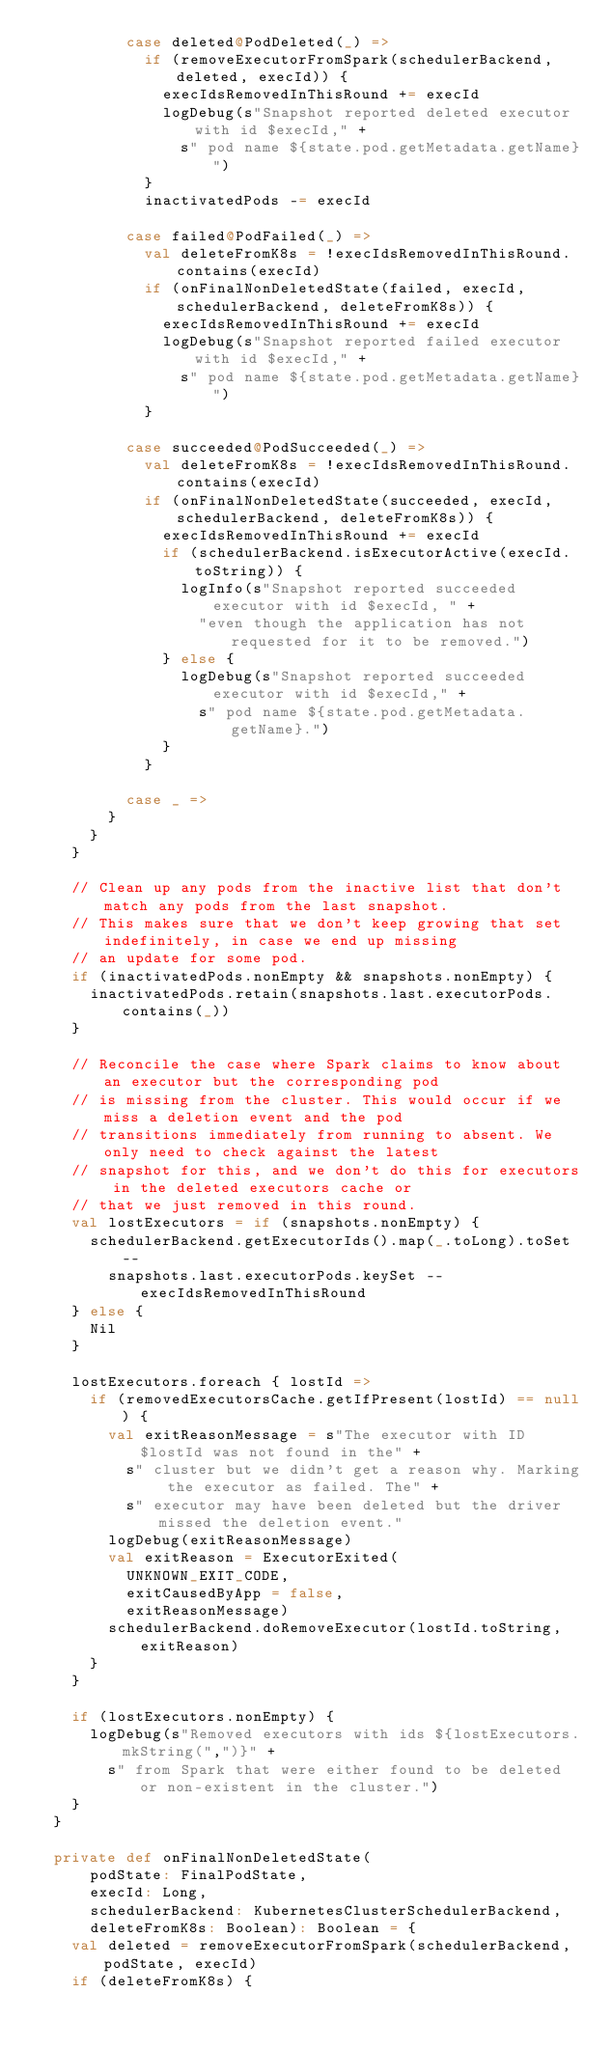<code> <loc_0><loc_0><loc_500><loc_500><_Scala_>          case deleted@PodDeleted(_) =>
            if (removeExecutorFromSpark(schedulerBackend, deleted, execId)) {
              execIdsRemovedInThisRound += execId
              logDebug(s"Snapshot reported deleted executor with id $execId," +
                s" pod name ${state.pod.getMetadata.getName}")
            }
            inactivatedPods -= execId

          case failed@PodFailed(_) =>
            val deleteFromK8s = !execIdsRemovedInThisRound.contains(execId)
            if (onFinalNonDeletedState(failed, execId, schedulerBackend, deleteFromK8s)) {
              execIdsRemovedInThisRound += execId
              logDebug(s"Snapshot reported failed executor with id $execId," +
                s" pod name ${state.pod.getMetadata.getName}")
            }

          case succeeded@PodSucceeded(_) =>
            val deleteFromK8s = !execIdsRemovedInThisRound.contains(execId)
            if (onFinalNonDeletedState(succeeded, execId, schedulerBackend, deleteFromK8s)) {
              execIdsRemovedInThisRound += execId
              if (schedulerBackend.isExecutorActive(execId.toString)) {
                logInfo(s"Snapshot reported succeeded executor with id $execId, " +
                  "even though the application has not requested for it to be removed.")
              } else {
                logDebug(s"Snapshot reported succeeded executor with id $execId," +
                  s" pod name ${state.pod.getMetadata.getName}.")
              }
            }

          case _ =>
        }
      }
    }

    // Clean up any pods from the inactive list that don't match any pods from the last snapshot.
    // This makes sure that we don't keep growing that set indefinitely, in case we end up missing
    // an update for some pod.
    if (inactivatedPods.nonEmpty && snapshots.nonEmpty) {
      inactivatedPods.retain(snapshots.last.executorPods.contains(_))
    }

    // Reconcile the case where Spark claims to know about an executor but the corresponding pod
    // is missing from the cluster. This would occur if we miss a deletion event and the pod
    // transitions immediately from running to absent. We only need to check against the latest
    // snapshot for this, and we don't do this for executors in the deleted executors cache or
    // that we just removed in this round.
    val lostExecutors = if (snapshots.nonEmpty) {
      schedulerBackend.getExecutorIds().map(_.toLong).toSet --
        snapshots.last.executorPods.keySet -- execIdsRemovedInThisRound
    } else {
      Nil
    }

    lostExecutors.foreach { lostId =>
      if (removedExecutorsCache.getIfPresent(lostId) == null) {
        val exitReasonMessage = s"The executor with ID $lostId was not found in the" +
          s" cluster but we didn't get a reason why. Marking the executor as failed. The" +
          s" executor may have been deleted but the driver missed the deletion event."
        logDebug(exitReasonMessage)
        val exitReason = ExecutorExited(
          UNKNOWN_EXIT_CODE,
          exitCausedByApp = false,
          exitReasonMessage)
        schedulerBackend.doRemoveExecutor(lostId.toString, exitReason)
      }
    }

    if (lostExecutors.nonEmpty) {
      logDebug(s"Removed executors with ids ${lostExecutors.mkString(",")}" +
        s" from Spark that were either found to be deleted or non-existent in the cluster.")
    }
  }

  private def onFinalNonDeletedState(
      podState: FinalPodState,
      execId: Long,
      schedulerBackend: KubernetesClusterSchedulerBackend,
      deleteFromK8s: Boolean): Boolean = {
    val deleted = removeExecutorFromSpark(schedulerBackend, podState, execId)
    if (deleteFromK8s) {</code> 